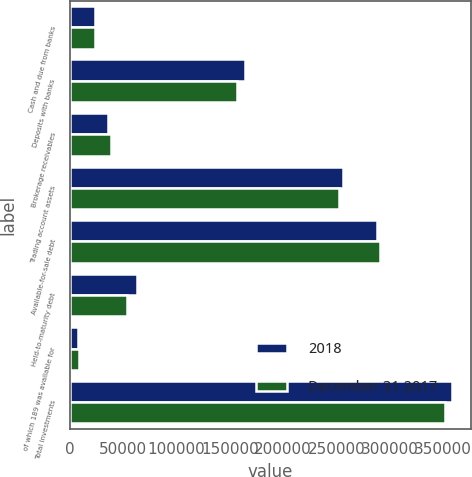Convert chart. <chart><loc_0><loc_0><loc_500><loc_500><stacked_bar_chart><ecel><fcel>Cash and due from banks<fcel>Deposits with banks<fcel>Brokerage receivables<fcel>Trading account assets<fcel>Available-for-sale debt<fcel>Held-to-maturity debt<fcel>of which 189 was available for<fcel>Total investments<nl><fcel>2018<fcel>23645<fcel>164460<fcel>35450<fcel>256117<fcel>288038<fcel>63357<fcel>7212<fcel>358607<nl><fcel>December 31 2017<fcel>23775<fcel>156741<fcel>38384<fcel>252790<fcel>290725<fcel>53320<fcel>8245<fcel>352290<nl></chart> 